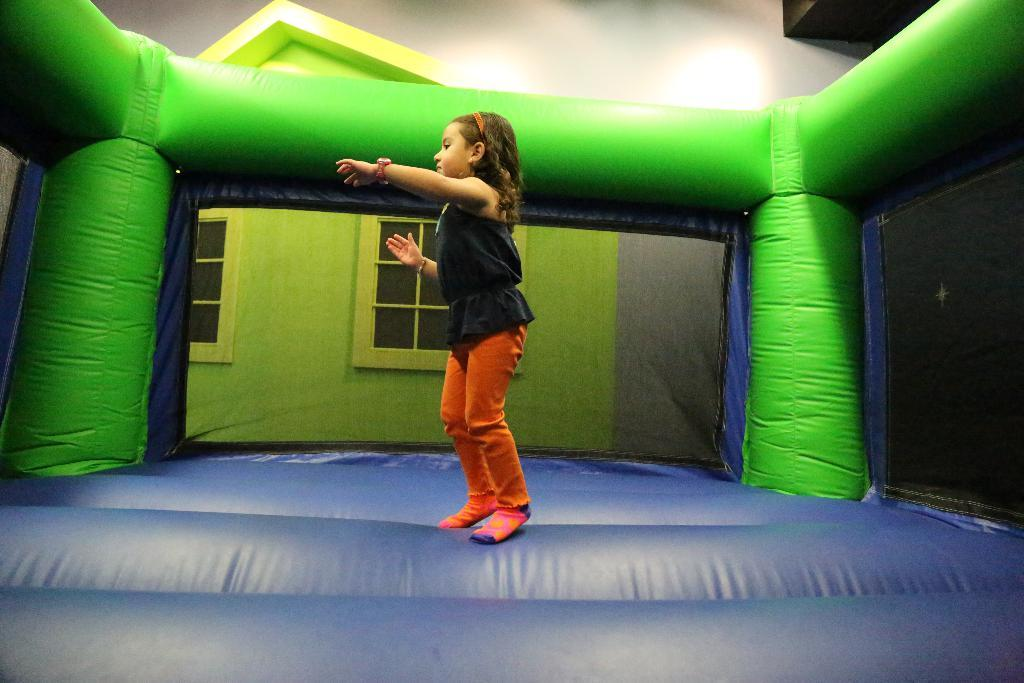Who is the main subject in the image? There is a girl in the image. What is the girl standing on? The girl is standing on an inflatable object. What can be seen in the background of the image? There are windows and a wall visible in the background of the image. What type of underwear is the girl wearing in the image? There is no information about the girl's underwear in the image, so it cannot be determined. 